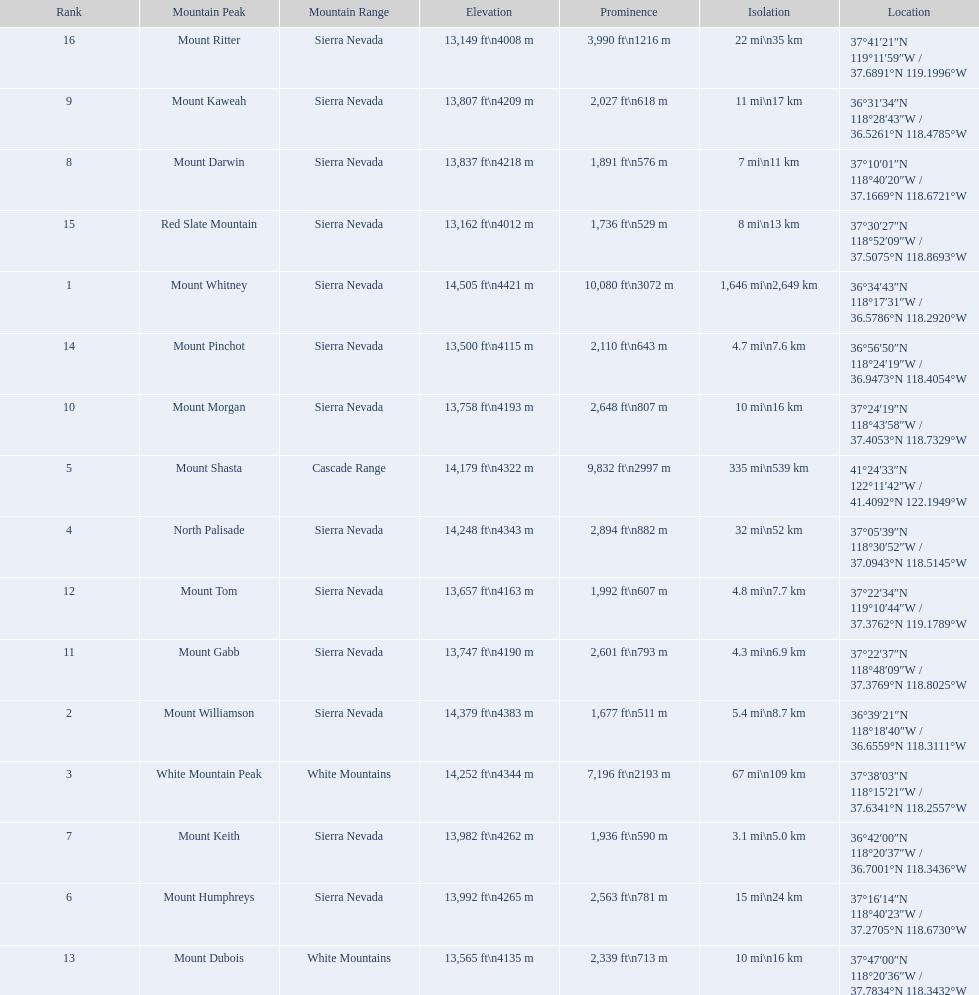What are the heights of the californian mountain peaks? 14,505 ft\n4421 m, 14,379 ft\n4383 m, 14,252 ft\n4344 m, 14,248 ft\n4343 m, 14,179 ft\n4322 m, 13,992 ft\n4265 m, 13,982 ft\n4262 m, 13,837 ft\n4218 m, 13,807 ft\n4209 m, 13,758 ft\n4193 m, 13,747 ft\n4190 m, 13,657 ft\n4163 m, 13,565 ft\n4135 m, 13,500 ft\n4115 m, 13,162 ft\n4012 m, 13,149 ft\n4008 m. What elevation is 13,149 ft or less? 13,149 ft\n4008 m. What mountain peak is at this elevation? Mount Ritter. Can you give me this table as a dict? {'header': ['Rank', 'Mountain Peak', 'Mountain Range', 'Elevation', 'Prominence', 'Isolation', 'Location'], 'rows': [['16', 'Mount Ritter', 'Sierra Nevada', '13,149\xa0ft\\n4008\xa0m', '3,990\xa0ft\\n1216\xa0m', '22\xa0mi\\n35\xa0km', '37°41′21″N 119°11′59″W\ufeff / \ufeff37.6891°N 119.1996°W'], ['9', 'Mount Kaweah', 'Sierra Nevada', '13,807\xa0ft\\n4209\xa0m', '2,027\xa0ft\\n618\xa0m', '11\xa0mi\\n17\xa0km', '36°31′34″N 118°28′43″W\ufeff / \ufeff36.5261°N 118.4785°W'], ['8', 'Mount Darwin', 'Sierra Nevada', '13,837\xa0ft\\n4218\xa0m', '1,891\xa0ft\\n576\xa0m', '7\xa0mi\\n11\xa0km', '37°10′01″N 118°40′20″W\ufeff / \ufeff37.1669°N 118.6721°W'], ['15', 'Red Slate Mountain', 'Sierra Nevada', '13,162\xa0ft\\n4012\xa0m', '1,736\xa0ft\\n529\xa0m', '8\xa0mi\\n13\xa0km', '37°30′27″N 118°52′09″W\ufeff / \ufeff37.5075°N 118.8693°W'], ['1', 'Mount Whitney', 'Sierra Nevada', '14,505\xa0ft\\n4421\xa0m', '10,080\xa0ft\\n3072\xa0m', '1,646\xa0mi\\n2,649\xa0km', '36°34′43″N 118°17′31″W\ufeff / \ufeff36.5786°N 118.2920°W'], ['14', 'Mount Pinchot', 'Sierra Nevada', '13,500\xa0ft\\n4115\xa0m', '2,110\xa0ft\\n643\xa0m', '4.7\xa0mi\\n7.6\xa0km', '36°56′50″N 118°24′19″W\ufeff / \ufeff36.9473°N 118.4054°W'], ['10', 'Mount Morgan', 'Sierra Nevada', '13,758\xa0ft\\n4193\xa0m', '2,648\xa0ft\\n807\xa0m', '10\xa0mi\\n16\xa0km', '37°24′19″N 118°43′58″W\ufeff / \ufeff37.4053°N 118.7329°W'], ['5', 'Mount Shasta', 'Cascade Range', '14,179\xa0ft\\n4322\xa0m', '9,832\xa0ft\\n2997\xa0m', '335\xa0mi\\n539\xa0km', '41°24′33″N 122°11′42″W\ufeff / \ufeff41.4092°N 122.1949°W'], ['4', 'North Palisade', 'Sierra Nevada', '14,248\xa0ft\\n4343\xa0m', '2,894\xa0ft\\n882\xa0m', '32\xa0mi\\n52\xa0km', '37°05′39″N 118°30′52″W\ufeff / \ufeff37.0943°N 118.5145°W'], ['12', 'Mount Tom', 'Sierra Nevada', '13,657\xa0ft\\n4163\xa0m', '1,992\xa0ft\\n607\xa0m', '4.8\xa0mi\\n7.7\xa0km', '37°22′34″N 119°10′44″W\ufeff / \ufeff37.3762°N 119.1789°W'], ['11', 'Mount Gabb', 'Sierra Nevada', '13,747\xa0ft\\n4190\xa0m', '2,601\xa0ft\\n793\xa0m', '4.3\xa0mi\\n6.9\xa0km', '37°22′37″N 118°48′09″W\ufeff / \ufeff37.3769°N 118.8025°W'], ['2', 'Mount Williamson', 'Sierra Nevada', '14,379\xa0ft\\n4383\xa0m', '1,677\xa0ft\\n511\xa0m', '5.4\xa0mi\\n8.7\xa0km', '36°39′21″N 118°18′40″W\ufeff / \ufeff36.6559°N 118.3111°W'], ['3', 'White Mountain Peak', 'White Mountains', '14,252\xa0ft\\n4344\xa0m', '7,196\xa0ft\\n2193\xa0m', '67\xa0mi\\n109\xa0km', '37°38′03″N 118°15′21″W\ufeff / \ufeff37.6341°N 118.2557°W'], ['7', 'Mount Keith', 'Sierra Nevada', '13,982\xa0ft\\n4262\xa0m', '1,936\xa0ft\\n590\xa0m', '3.1\xa0mi\\n5.0\xa0km', '36°42′00″N 118°20′37″W\ufeff / \ufeff36.7001°N 118.3436°W'], ['6', 'Mount Humphreys', 'Sierra Nevada', '13,992\xa0ft\\n4265\xa0m', '2,563\xa0ft\\n781\xa0m', '15\xa0mi\\n24\xa0km', '37°16′14″N 118°40′23″W\ufeff / \ufeff37.2705°N 118.6730°W'], ['13', 'Mount Dubois', 'White Mountains', '13,565\xa0ft\\n4135\xa0m', '2,339\xa0ft\\n713\xa0m', '10\xa0mi\\n16\xa0km', '37°47′00″N 118°20′36″W\ufeff / \ufeff37.7834°N 118.3432°W']]} 